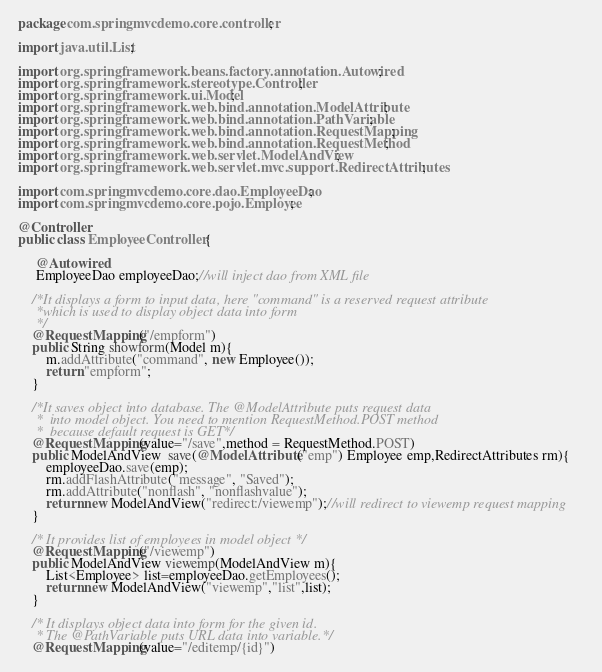Convert code to text. <code><loc_0><loc_0><loc_500><loc_500><_Java_>package com.springmvcdemo.core.controller;

import java.util.List;

import org.springframework.beans.factory.annotation.Autowired;
import org.springframework.stereotype.Controller;
import org.springframework.ui.Model;
import org.springframework.web.bind.annotation.ModelAttribute;
import org.springframework.web.bind.annotation.PathVariable;
import org.springframework.web.bind.annotation.RequestMapping;
import org.springframework.web.bind.annotation.RequestMethod;
import org.springframework.web.servlet.ModelAndView;
import org.springframework.web.servlet.mvc.support.RedirectAttributes;

import com.springmvcdemo.core.dao.EmployeeDao;
import com.springmvcdemo.core.pojo.Employee;

@Controller
public class EmployeeController {

	 @Autowired    
	 EmployeeDao employeeDao;//will inject dao from XML file    
	        
    /*It displays a form to input data, here "command" is a reserved request attribute  
     *which is used to display object data into form  
     */    
    @RequestMapping("/empform")    
    public String showform(Model m){    
        m.addAttribute("command", new Employee());  
        return "empform";   
    }
    
    /*It saves object into database. The @ModelAttribute puts request data  
     *  into model object. You need to mention RequestMethod.POST method   
     *  because default request is GET*/    
    @RequestMapping(value="/save",method = RequestMethod.POST)    
    public ModelAndView  save(@ModelAttribute("emp") Employee emp,RedirectAttributes rm){    
        employeeDao.save(emp);   
        rm.addFlashAttribute("message", "Saved");
        rm.addAttribute("nonflash", "nonflashvalue");
        return new ModelAndView("redirect:/viewemp");//will redirect to viewemp request mapping    
    }
    
    /* It provides list of employees in model object */    
    @RequestMapping("/viewemp")    
    public ModelAndView viewemp(ModelAndView m){    
        List<Employee> list=employeeDao.getEmployees();    
        return new ModelAndView("viewemp","list",list);    
    }
    
    /* It displays object data into form for the given id.   
     * The @PathVariable puts URL data into variable.*/    
    @RequestMapping(value="/editemp/{id}")    </code> 